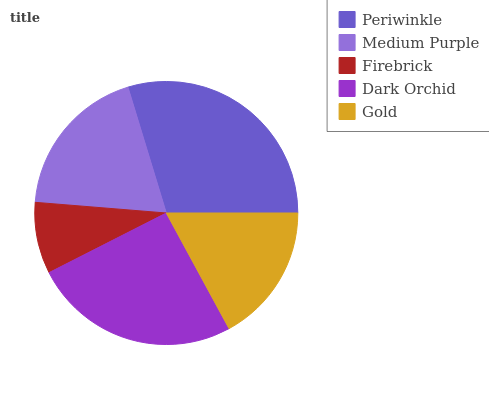Is Firebrick the minimum?
Answer yes or no. Yes. Is Periwinkle the maximum?
Answer yes or no. Yes. Is Medium Purple the minimum?
Answer yes or no. No. Is Medium Purple the maximum?
Answer yes or no. No. Is Periwinkle greater than Medium Purple?
Answer yes or no. Yes. Is Medium Purple less than Periwinkle?
Answer yes or no. Yes. Is Medium Purple greater than Periwinkle?
Answer yes or no. No. Is Periwinkle less than Medium Purple?
Answer yes or no. No. Is Medium Purple the high median?
Answer yes or no. Yes. Is Medium Purple the low median?
Answer yes or no. Yes. Is Firebrick the high median?
Answer yes or no. No. Is Dark Orchid the low median?
Answer yes or no. No. 